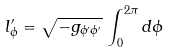Convert formula to latex. <formula><loc_0><loc_0><loc_500><loc_500>l ^ { \prime } _ { \phi } = \sqrt { - g _ { \phi ^ { \prime } \phi ^ { \prime } } } \, \int _ { 0 } ^ { 2 \pi } { d \phi }</formula> 